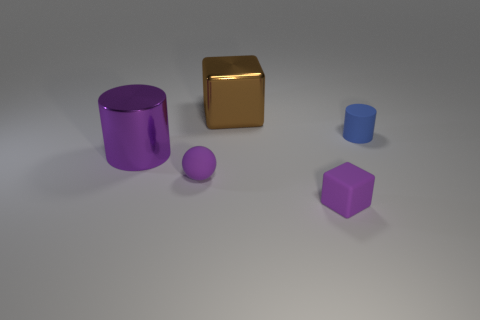Add 5 matte things. How many objects exist? 10 Subtract 0 gray spheres. How many objects are left? 5 Subtract all cylinders. How many objects are left? 3 Subtract all small purple rubber balls. Subtract all tiny purple cubes. How many objects are left? 3 Add 5 tiny blue matte cylinders. How many tiny blue matte cylinders are left? 6 Add 4 tiny blue cylinders. How many tiny blue cylinders exist? 5 